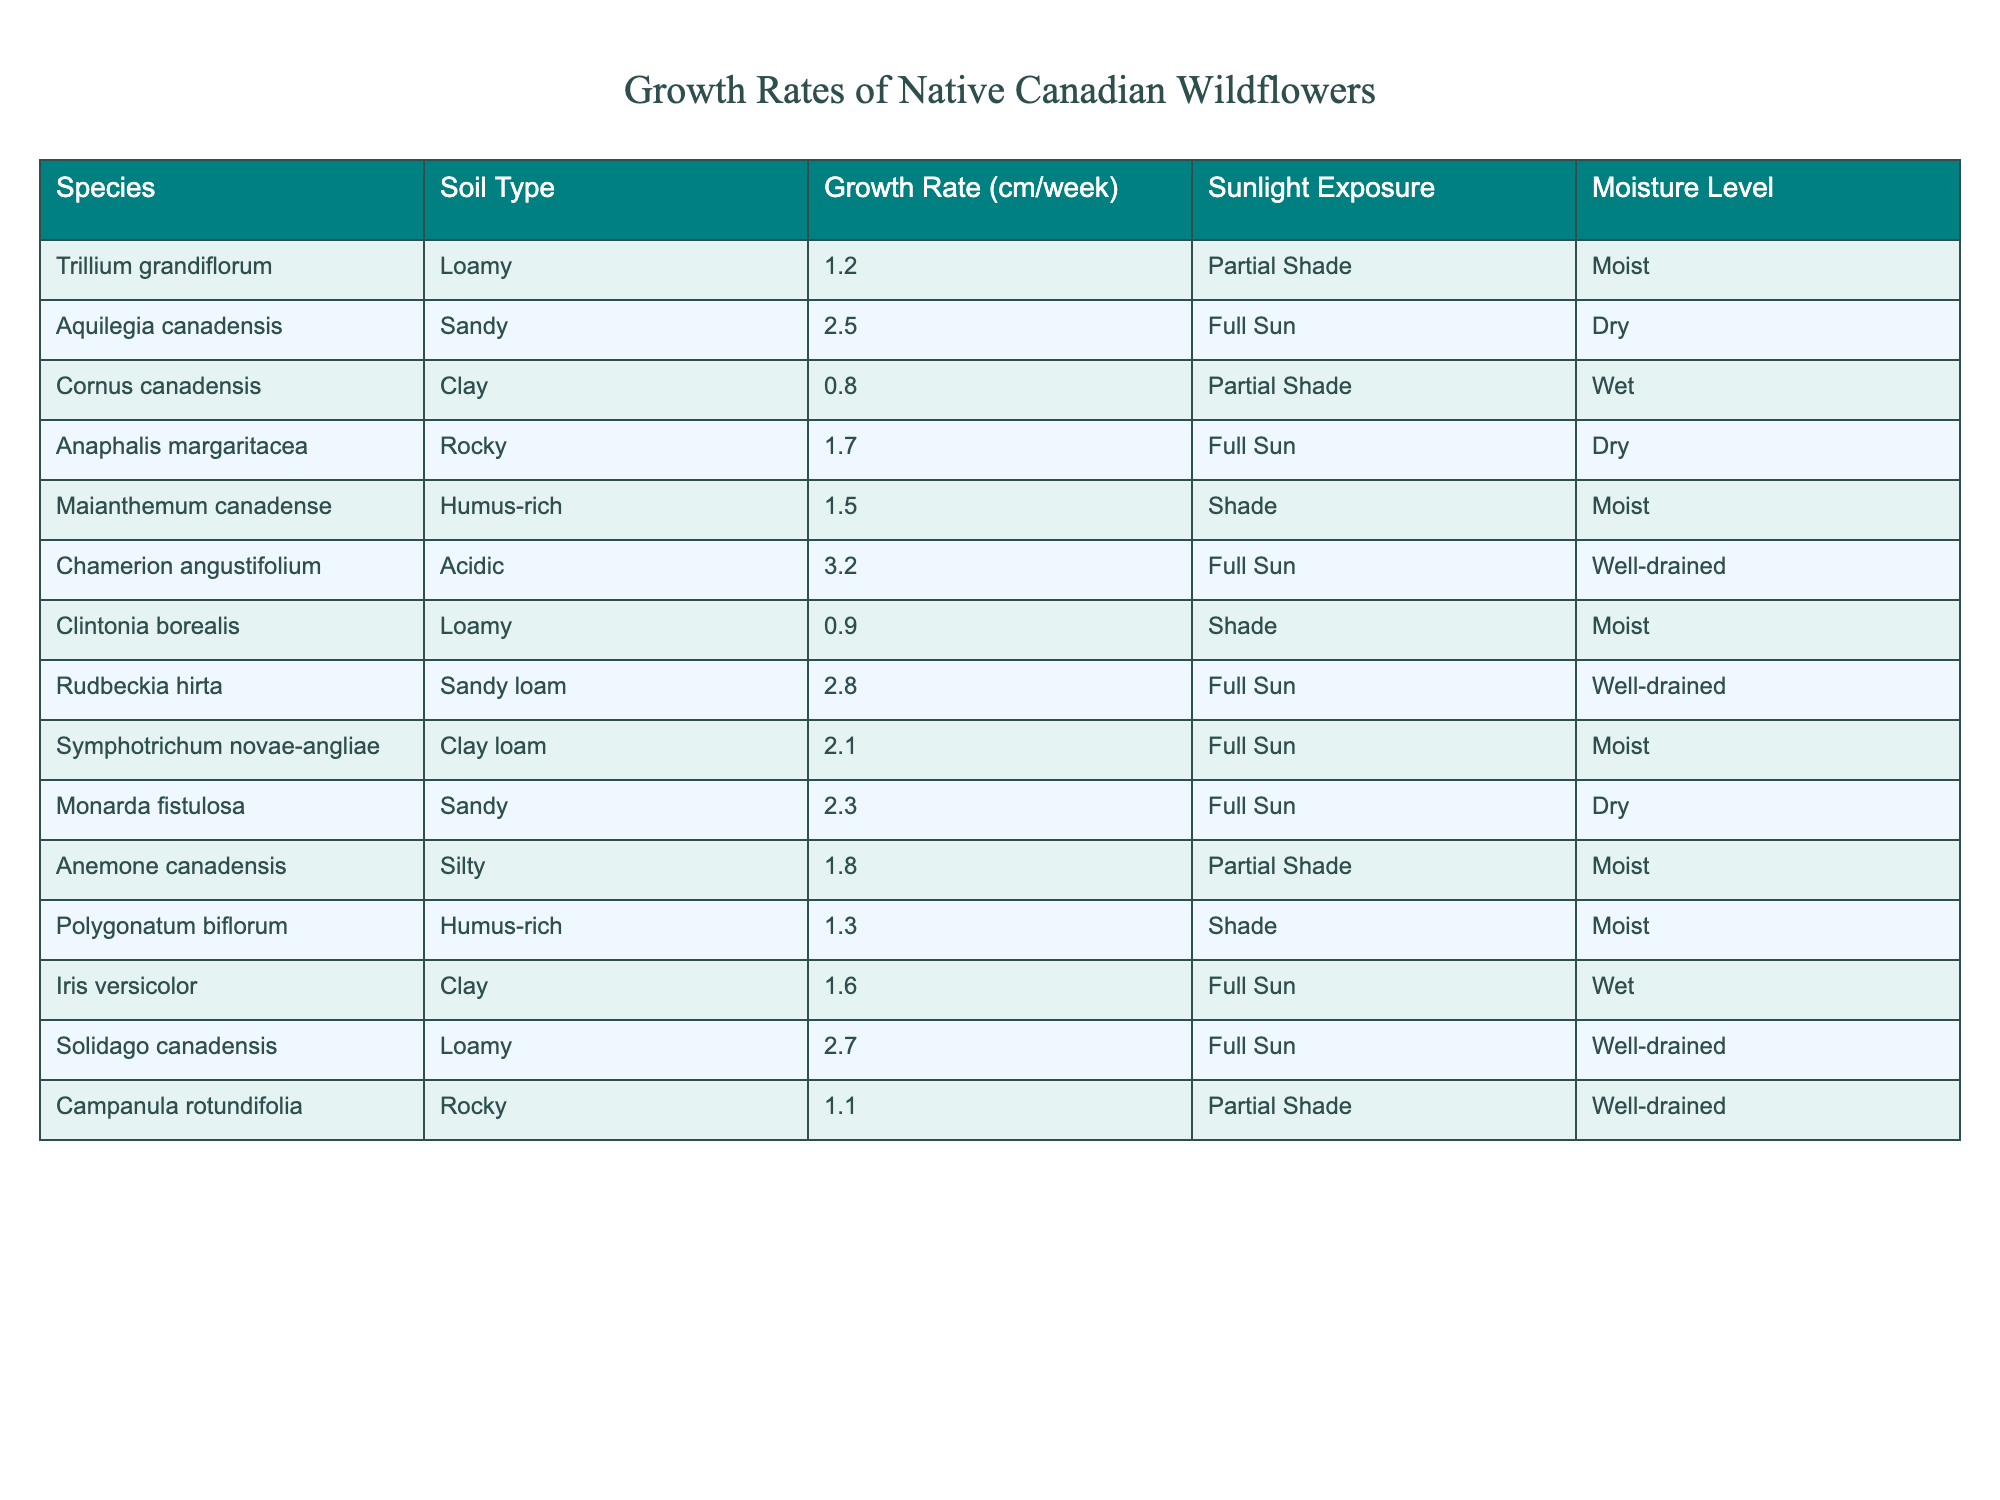What is the growth rate of Aquilegia canadensis? Looking at the table, the growth rate for Aquilegia canadensis under the Sandy soil type is listed as 2.5 cm/week.
Answer: 2.5 cm/week Which species has the highest growth rate? By comparing all the growth rates, Chamerion angustifolium has the highest growth rate at 3.2 cm/week.
Answer: Chamerion angustiflorium What is the growth rate of plants in Humus-rich soil? The species in Humus-rich soil are Maianthemum canadense (1.5 cm/week) and Polygonatum biflorum (1.3 cm/week). Their average growth rate is (1.5 + 1.3) / 2 = 1.4 cm/week.
Answer: 1.4 cm/week Do any wildflowers grow faster in Sandy soil than in Clay soil? In the table, in Sandy soil, the growth rates are 2.5 cm/week (Aquilegia canadensis), 2.3 cm/week (Monarda fistulosa), and 2.8 cm/week (Rudbeckia hirta). In Clay soil, the highest growth rate is 1.6 cm/week (Iris versicolor). Since all sandy soil rates exceed the highest clay rate, the answer is yes.
Answer: Yes What is the average growth rate of wildflowers exposed to Full Sun? The species with Full Sun exposure are Aquilegia canadensis (2.5 cm/week), Anaphalis margaritacea (1.7 cm/week), Chamerion angustifolium (3.2 cm/week), Rudbeckia hirta (2.8 cm/week), Monarda fistulosa (2.3 cm/week), and Symphotrichum novae-angliae (2.1 cm/week). Summing these gives (2.5 + 1.7 + 3.2 + 2.8 + 2.3 + 2.1) = 14.6 cm/week. Dividing by 6 (the number of species) results in an average growth rate of approximately 2.43 cm/week.
Answer: 2.43 cm/week Which soil type has the plant with the lowest growth rate? By checking the growth rates, Cornus canadensis has the lowest growth rate of 0.8 cm/week in Clay soil.
Answer: Clay soil Is it true that all wildflowers in the table prefer moist soil? Looking through the moisture levels for each flower, some species indicated 'Dry', such as Aquilegia canadensis and Monarda fistulosa. Therefore, it isn't true that all wildflowers prefer moist soil.
Answer: No What is the difference in growth rates between the fastest and slowest growing wildflowers? From the table, the fastest growing flower is Chamerion angustifolium at 3.2 cm/week and the slowest is Cornus canadensis at 0.8 cm/week. The difference is 3.2 - 0.8 = 2.4 cm/week.
Answer: 2.4 cm/week Among the wildflowers, which one grows in the driest conditions? The driest conditions indicated in the table are 'Dry,' which corresponds to Aquilegia canadensis (2.5 cm/week), Anaphalis margaritacea (1.7 cm/week), and Monarda fistulosa (2.3 cm/week). Therefore, Aquilegia canadensis is among those that grow in the driest conditions.
Answer: Aquilegia canadensis 